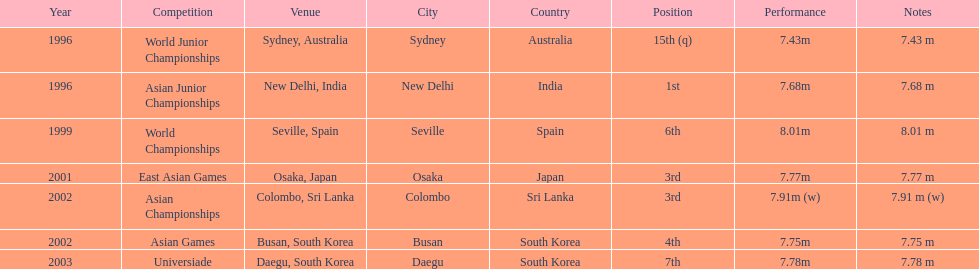Which competition did this person compete in immediately before the east asian games in 2001? World Championships. 